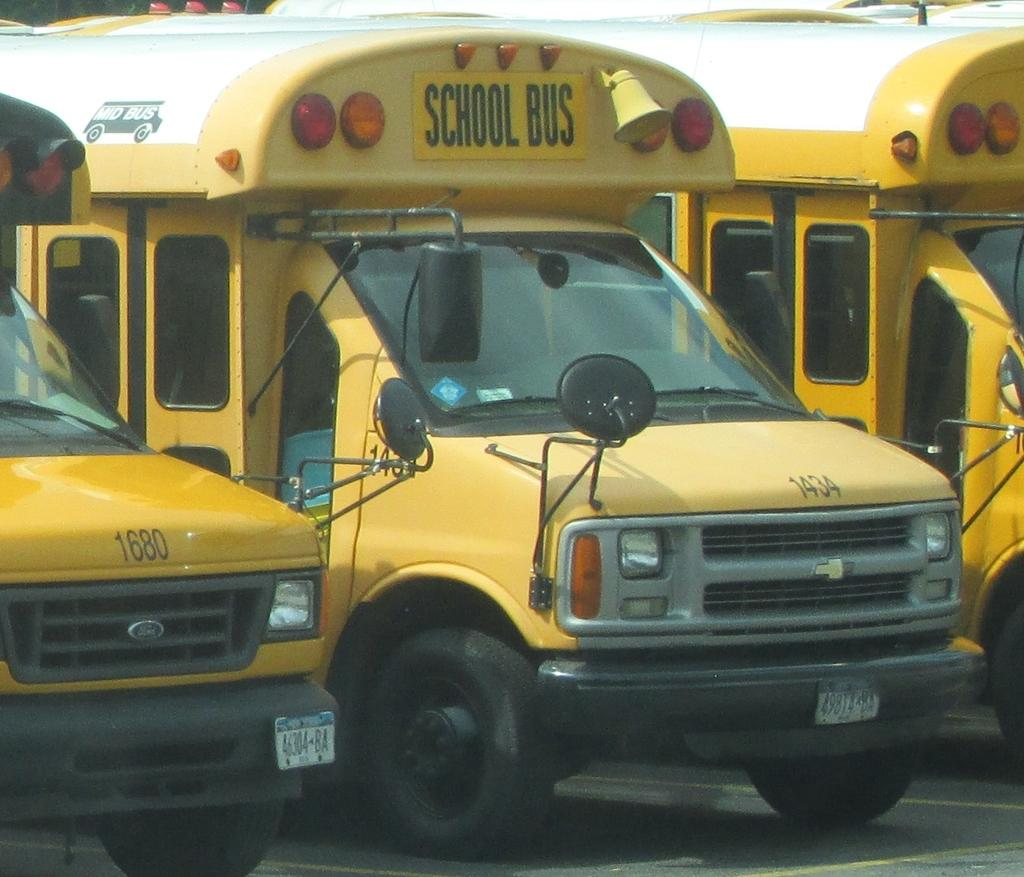<image>
Create a compact narrative representing the image presented. A line of school buses, including buses number 1680 and 1434. 